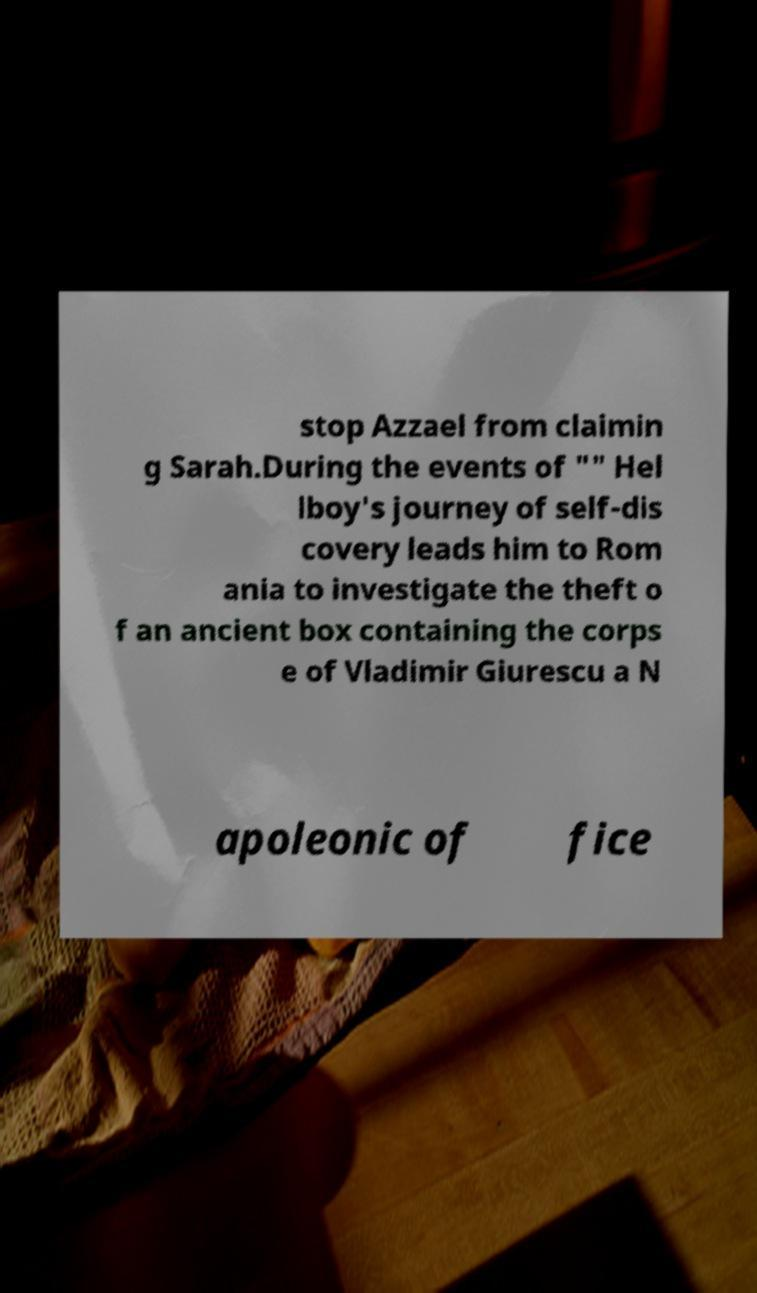There's text embedded in this image that I need extracted. Can you transcribe it verbatim? stop Azzael from claimin g Sarah.During the events of "" Hel lboy's journey of self-dis covery leads him to Rom ania to investigate the theft o f an ancient box containing the corps e of Vladimir Giurescu a N apoleonic of fice 